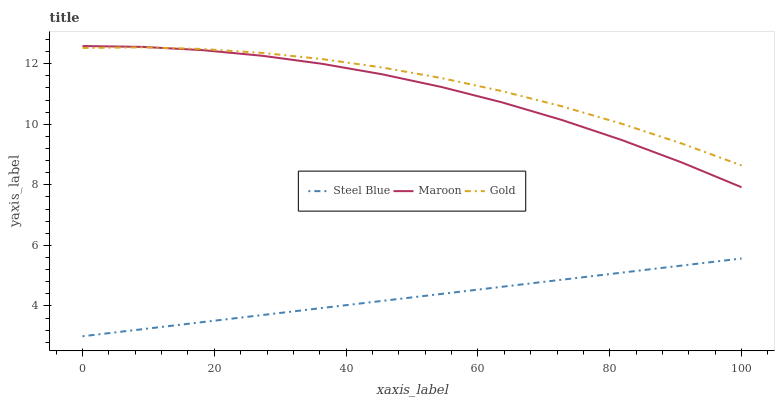Does Steel Blue have the minimum area under the curve?
Answer yes or no. Yes. Does Gold have the maximum area under the curve?
Answer yes or no. Yes. Does Maroon have the minimum area under the curve?
Answer yes or no. No. Does Maroon have the maximum area under the curve?
Answer yes or no. No. Is Steel Blue the smoothest?
Answer yes or no. Yes. Is Maroon the roughest?
Answer yes or no. Yes. Is Maroon the smoothest?
Answer yes or no. No. Is Steel Blue the roughest?
Answer yes or no. No. Does Steel Blue have the lowest value?
Answer yes or no. Yes. Does Maroon have the lowest value?
Answer yes or no. No. Does Maroon have the highest value?
Answer yes or no. Yes. Does Steel Blue have the highest value?
Answer yes or no. No. Is Steel Blue less than Gold?
Answer yes or no. Yes. Is Maroon greater than Steel Blue?
Answer yes or no. Yes. Does Maroon intersect Gold?
Answer yes or no. Yes. Is Maroon less than Gold?
Answer yes or no. No. Is Maroon greater than Gold?
Answer yes or no. No. Does Steel Blue intersect Gold?
Answer yes or no. No. 